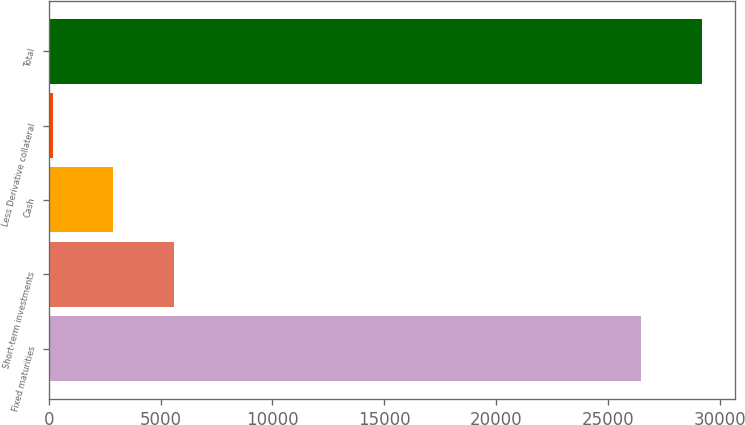Convert chart to OTSL. <chart><loc_0><loc_0><loc_500><loc_500><bar_chart><fcel>Fixed maturities<fcel>Short-term investments<fcel>Cash<fcel>Less Derivative collateral<fcel>Total<nl><fcel>26503<fcel>5600.4<fcel>2884.7<fcel>169<fcel>29218.7<nl></chart> 